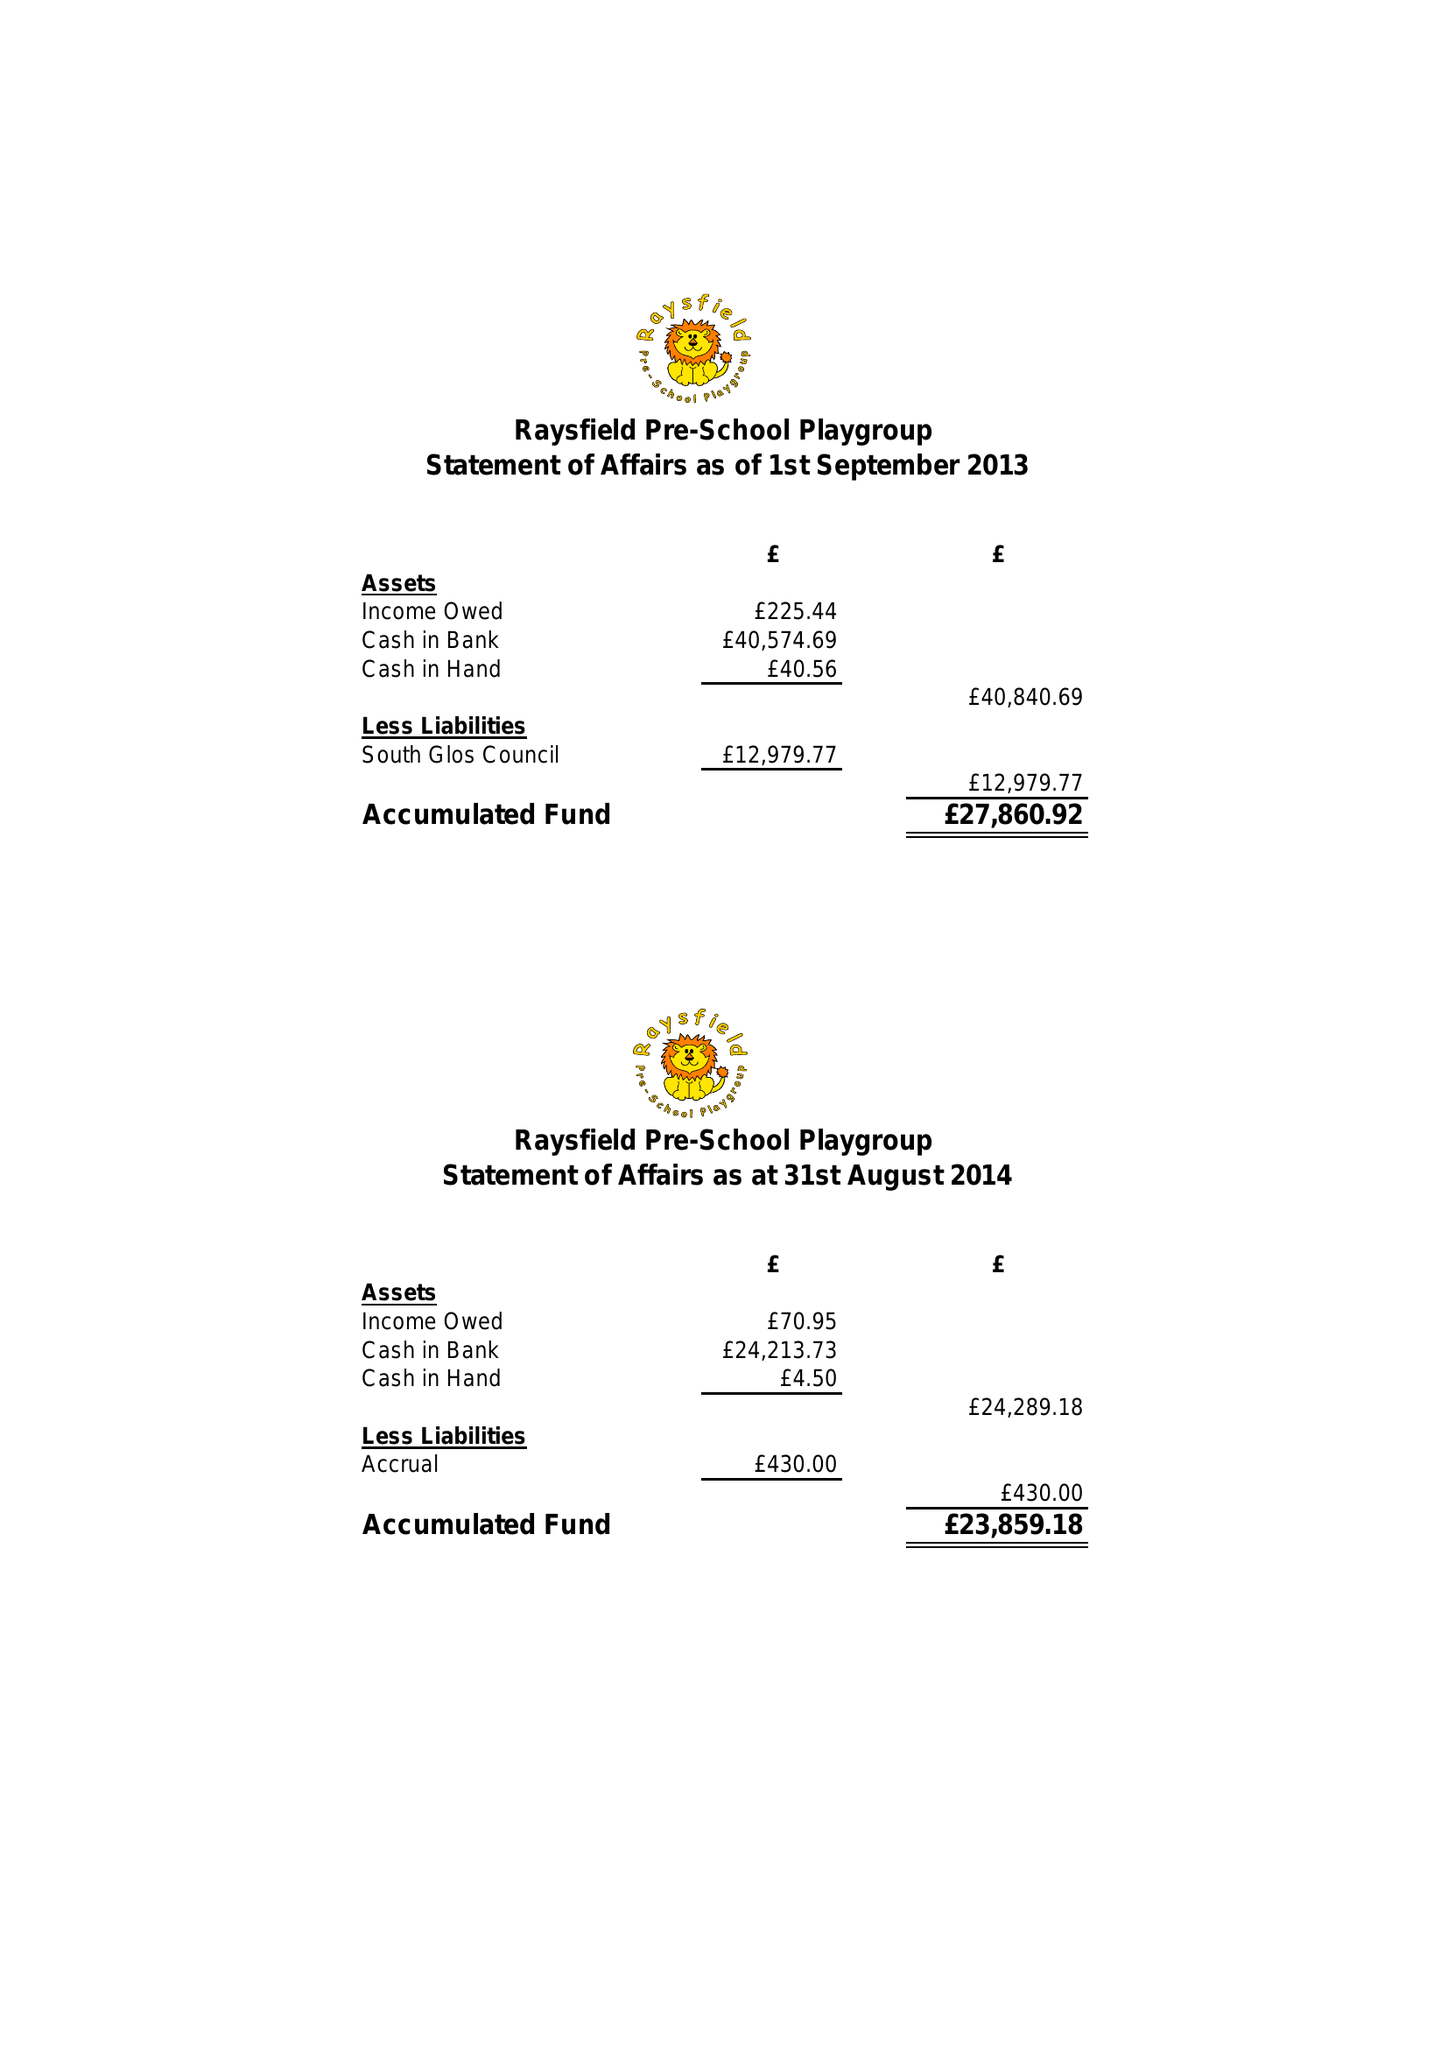What is the value for the spending_annually_in_british_pounds?
Answer the question using a single word or phrase. 83763.10 